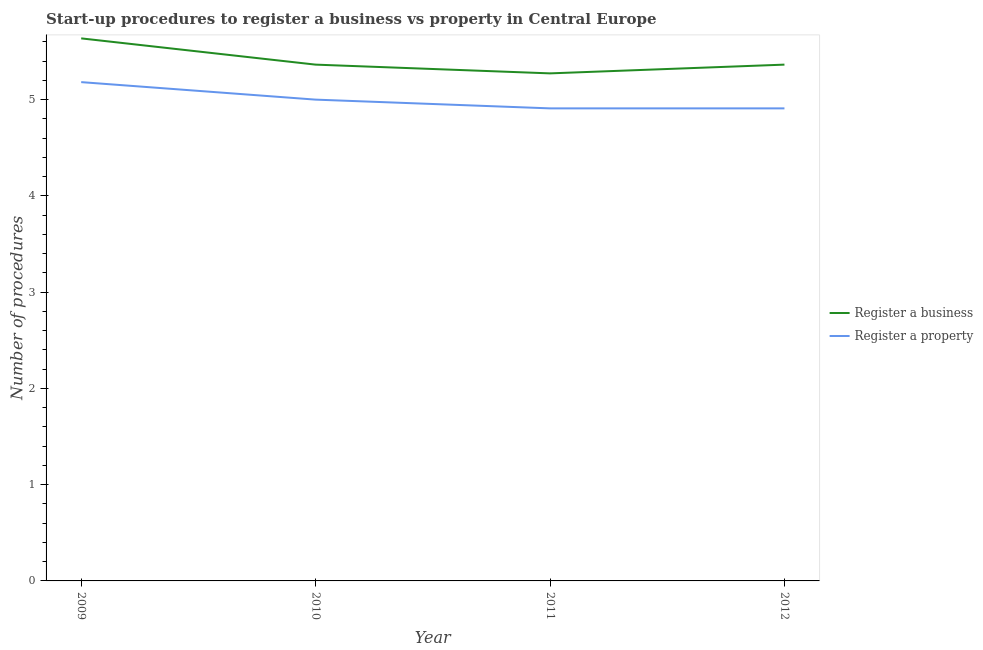Does the line corresponding to number of procedures to register a business intersect with the line corresponding to number of procedures to register a property?
Offer a terse response. No. What is the number of procedures to register a business in 2010?
Your answer should be compact. 5.36. Across all years, what is the maximum number of procedures to register a business?
Offer a very short reply. 5.64. Across all years, what is the minimum number of procedures to register a property?
Your response must be concise. 4.91. In which year was the number of procedures to register a business maximum?
Provide a succinct answer. 2009. In which year was the number of procedures to register a property minimum?
Ensure brevity in your answer.  2011. What is the total number of procedures to register a business in the graph?
Offer a terse response. 21.64. What is the difference between the number of procedures to register a business in 2009 and that in 2012?
Ensure brevity in your answer.  0.27. What is the difference between the number of procedures to register a property in 2011 and the number of procedures to register a business in 2009?
Your answer should be compact. -0.73. What is the average number of procedures to register a property per year?
Make the answer very short. 5. In the year 2009, what is the difference between the number of procedures to register a property and number of procedures to register a business?
Your response must be concise. -0.45. In how many years, is the number of procedures to register a property greater than 0.4?
Provide a succinct answer. 4. What is the ratio of the number of procedures to register a property in 2009 to that in 2012?
Provide a short and direct response. 1.06. What is the difference between the highest and the second highest number of procedures to register a business?
Make the answer very short. 0.27. What is the difference between the highest and the lowest number of procedures to register a business?
Provide a succinct answer. 0.36. Is the sum of the number of procedures to register a business in 2009 and 2011 greater than the maximum number of procedures to register a property across all years?
Offer a very short reply. Yes. Does the number of procedures to register a property monotonically increase over the years?
Ensure brevity in your answer.  No. What is the difference between two consecutive major ticks on the Y-axis?
Offer a very short reply. 1. Are the values on the major ticks of Y-axis written in scientific E-notation?
Provide a short and direct response. No. Does the graph contain any zero values?
Ensure brevity in your answer.  No. How many legend labels are there?
Your answer should be compact. 2. How are the legend labels stacked?
Provide a succinct answer. Vertical. What is the title of the graph?
Your answer should be very brief. Start-up procedures to register a business vs property in Central Europe. Does "By country of asylum" appear as one of the legend labels in the graph?
Offer a very short reply. No. What is the label or title of the Y-axis?
Offer a very short reply. Number of procedures. What is the Number of procedures in Register a business in 2009?
Provide a succinct answer. 5.64. What is the Number of procedures of Register a property in 2009?
Ensure brevity in your answer.  5.18. What is the Number of procedures in Register a business in 2010?
Give a very brief answer. 5.36. What is the Number of procedures of Register a property in 2010?
Your answer should be very brief. 5. What is the Number of procedures of Register a business in 2011?
Your response must be concise. 5.27. What is the Number of procedures in Register a property in 2011?
Your answer should be very brief. 4.91. What is the Number of procedures of Register a business in 2012?
Ensure brevity in your answer.  5.36. What is the Number of procedures in Register a property in 2012?
Ensure brevity in your answer.  4.91. Across all years, what is the maximum Number of procedures in Register a business?
Your answer should be compact. 5.64. Across all years, what is the maximum Number of procedures of Register a property?
Make the answer very short. 5.18. Across all years, what is the minimum Number of procedures in Register a business?
Provide a short and direct response. 5.27. Across all years, what is the minimum Number of procedures in Register a property?
Your answer should be compact. 4.91. What is the total Number of procedures of Register a business in the graph?
Provide a short and direct response. 21.64. What is the total Number of procedures in Register a property in the graph?
Your answer should be very brief. 20. What is the difference between the Number of procedures of Register a business in 2009 and that in 2010?
Offer a terse response. 0.27. What is the difference between the Number of procedures of Register a property in 2009 and that in 2010?
Your answer should be compact. 0.18. What is the difference between the Number of procedures of Register a business in 2009 and that in 2011?
Your answer should be compact. 0.36. What is the difference between the Number of procedures in Register a property in 2009 and that in 2011?
Your answer should be very brief. 0.27. What is the difference between the Number of procedures in Register a business in 2009 and that in 2012?
Your answer should be compact. 0.27. What is the difference between the Number of procedures of Register a property in 2009 and that in 2012?
Keep it short and to the point. 0.27. What is the difference between the Number of procedures of Register a business in 2010 and that in 2011?
Offer a terse response. 0.09. What is the difference between the Number of procedures in Register a property in 2010 and that in 2011?
Your answer should be compact. 0.09. What is the difference between the Number of procedures in Register a property in 2010 and that in 2012?
Provide a succinct answer. 0.09. What is the difference between the Number of procedures in Register a business in 2011 and that in 2012?
Offer a very short reply. -0.09. What is the difference between the Number of procedures of Register a business in 2009 and the Number of procedures of Register a property in 2010?
Offer a very short reply. 0.64. What is the difference between the Number of procedures of Register a business in 2009 and the Number of procedures of Register a property in 2011?
Your response must be concise. 0.73. What is the difference between the Number of procedures of Register a business in 2009 and the Number of procedures of Register a property in 2012?
Offer a terse response. 0.73. What is the difference between the Number of procedures in Register a business in 2010 and the Number of procedures in Register a property in 2011?
Your response must be concise. 0.45. What is the difference between the Number of procedures in Register a business in 2010 and the Number of procedures in Register a property in 2012?
Provide a succinct answer. 0.45. What is the difference between the Number of procedures of Register a business in 2011 and the Number of procedures of Register a property in 2012?
Your answer should be very brief. 0.36. What is the average Number of procedures in Register a business per year?
Your answer should be very brief. 5.41. In the year 2009, what is the difference between the Number of procedures in Register a business and Number of procedures in Register a property?
Provide a succinct answer. 0.45. In the year 2010, what is the difference between the Number of procedures in Register a business and Number of procedures in Register a property?
Provide a short and direct response. 0.36. In the year 2011, what is the difference between the Number of procedures in Register a business and Number of procedures in Register a property?
Offer a terse response. 0.36. In the year 2012, what is the difference between the Number of procedures of Register a business and Number of procedures of Register a property?
Ensure brevity in your answer.  0.45. What is the ratio of the Number of procedures in Register a business in 2009 to that in 2010?
Offer a very short reply. 1.05. What is the ratio of the Number of procedures in Register a property in 2009 to that in 2010?
Your response must be concise. 1.04. What is the ratio of the Number of procedures of Register a business in 2009 to that in 2011?
Make the answer very short. 1.07. What is the ratio of the Number of procedures in Register a property in 2009 to that in 2011?
Make the answer very short. 1.06. What is the ratio of the Number of procedures of Register a business in 2009 to that in 2012?
Your response must be concise. 1.05. What is the ratio of the Number of procedures of Register a property in 2009 to that in 2012?
Ensure brevity in your answer.  1.06. What is the ratio of the Number of procedures of Register a business in 2010 to that in 2011?
Give a very brief answer. 1.02. What is the ratio of the Number of procedures in Register a property in 2010 to that in 2011?
Keep it short and to the point. 1.02. What is the ratio of the Number of procedures of Register a business in 2010 to that in 2012?
Make the answer very short. 1. What is the ratio of the Number of procedures in Register a property in 2010 to that in 2012?
Ensure brevity in your answer.  1.02. What is the ratio of the Number of procedures in Register a business in 2011 to that in 2012?
Keep it short and to the point. 0.98. What is the ratio of the Number of procedures of Register a property in 2011 to that in 2012?
Make the answer very short. 1. What is the difference between the highest and the second highest Number of procedures in Register a business?
Provide a short and direct response. 0.27. What is the difference between the highest and the second highest Number of procedures in Register a property?
Make the answer very short. 0.18. What is the difference between the highest and the lowest Number of procedures of Register a business?
Your answer should be very brief. 0.36. What is the difference between the highest and the lowest Number of procedures of Register a property?
Offer a terse response. 0.27. 